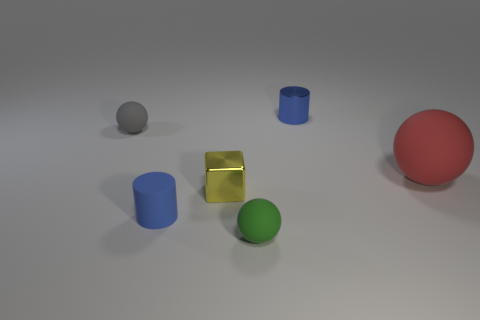There is another cylinder that is the same color as the rubber cylinder; what material is it?
Make the answer very short. Metal. How many objects are either matte things that are left of the blue metallic object or tiny blue things that are in front of the blue metallic cylinder?
Ensure brevity in your answer.  3. Are there fewer gray rubber things than tiny things?
Make the answer very short. Yes. There is a yellow shiny thing that is the same size as the gray rubber sphere; what shape is it?
Provide a short and direct response. Cube. How many other objects are the same color as the cube?
Offer a terse response. 0. What number of tiny green cylinders are there?
Your answer should be compact. 0. How many tiny blue cylinders are both behind the blue rubber object and on the left side of the green object?
Ensure brevity in your answer.  0. What is the tiny green sphere made of?
Offer a very short reply. Rubber. Are there any small cyan blocks?
Offer a very short reply. No. The tiny sphere that is to the right of the gray ball is what color?
Your answer should be compact. Green. 